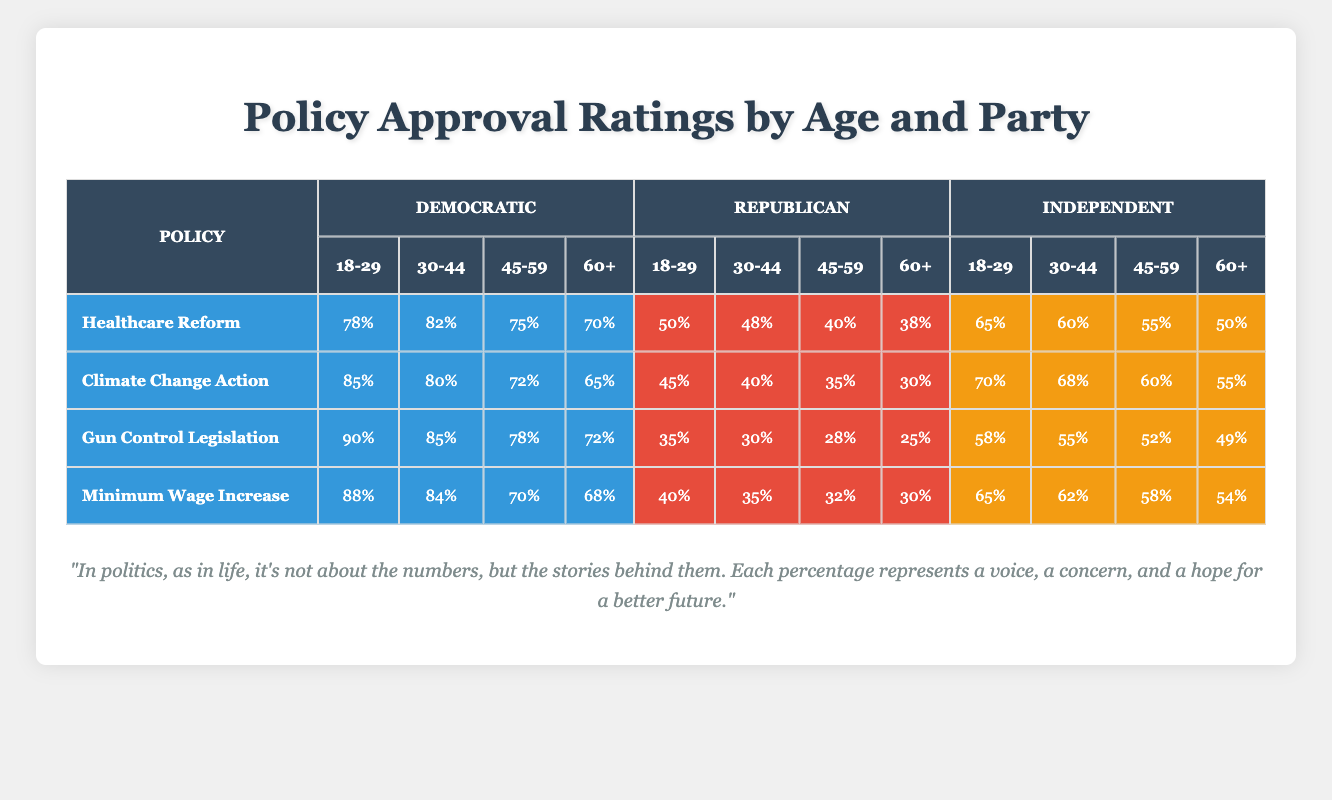What is the approval rating for Healthcare Reform among Republicans aged 60 and older? From the table, under the Healthcare Reform policy, the approval rating for Republicans in the age group 60+ is listed as 38%.
Answer: 38% Which age group has the highest approval rating for Gun Control Legislation among Democrats? Looking at the table for Gun Control Legislation under the Democratic column, the age group 18-29 has the highest rating at 90%.
Answer: 90% What is the difference in approval ratings for Climate Change Action between Democratic and Republican voters aged 30-44? The approval rating for Climate Change Action among Democrats aged 30-44 is 80%, while for Republicans it is 40%. The difference is 80% - 40% = 40%.
Answer: 40% Is the approval rating for the Minimum Wage Increase higher among Independents aged 45-59 or 60+? Checking the table, Independents have a 58% approval rating for Minimum Wage Increase aged 45-59 and 54% for aged 60+. Since 58% is greater than 54%, it is higher for the 45-59 age group.
Answer: Yes What is the average approval rating for Healthcare Reform among all party alignments in the age group 18-29? The ratings for Healthcare Reform among 18-29 year-olds are 78% (Democratic), 50% (Republican), and 65% (Independent). Adding these values gives 78 + 50 + 65 = 193, and dividing by 3 (the number of values) gives an average of 193 / 3 ≈ 64.33%.
Answer: 64.33% 